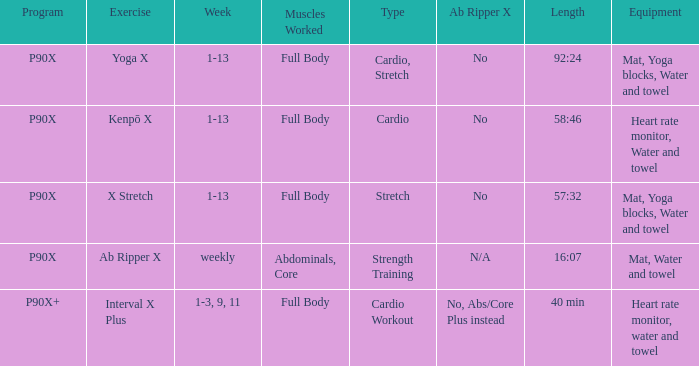Write the full table. {'header': ['Program', 'Exercise', 'Week', 'Muscles Worked', 'Type', 'Ab Ripper X', 'Length', 'Equipment'], 'rows': [['P90X', 'Yoga X', '1-13', 'Full Body', 'Cardio, Stretch', 'No', '92:24', 'Mat, Yoga blocks, Water and towel'], ['P90X', 'Kenpō X', '1-13', 'Full Body', 'Cardio', 'No', '58:46', 'Heart rate monitor, Water and towel'], ['P90X', 'X Stretch', '1-13', 'Full Body', 'Stretch', 'No', '57:32', 'Mat, Yoga blocks, Water and towel'], ['P90X', 'Ab Ripper X', 'weekly', 'Abdominals, Core', 'Strength Training', 'N/A', '16:07', 'Mat, Water and towel'], ['P90X+', 'Interval X Plus', '1-3, 9, 11', 'Full Body', 'Cardio Workout', 'No, Abs/Core Plus instead', '40 min', 'Heart rate monitor, water and towel']]} What is the week when the kind is cardio exercise? 1-3, 9, 11. 